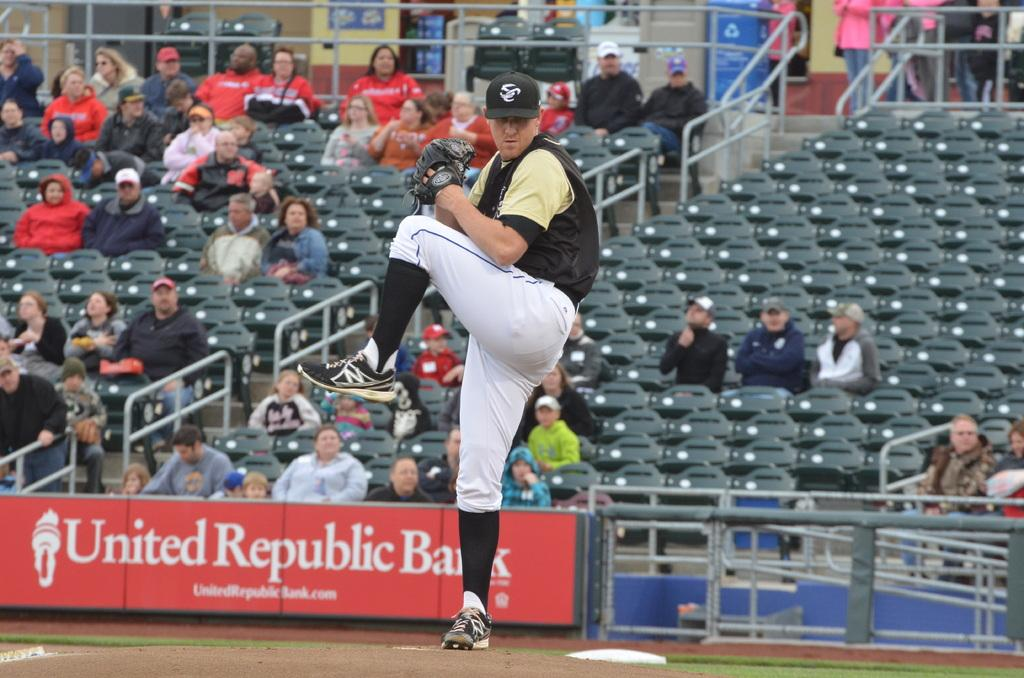<image>
Provide a brief description of the given image. A sign for the United Republic Bank sits at the edge of a baseball stadium. 